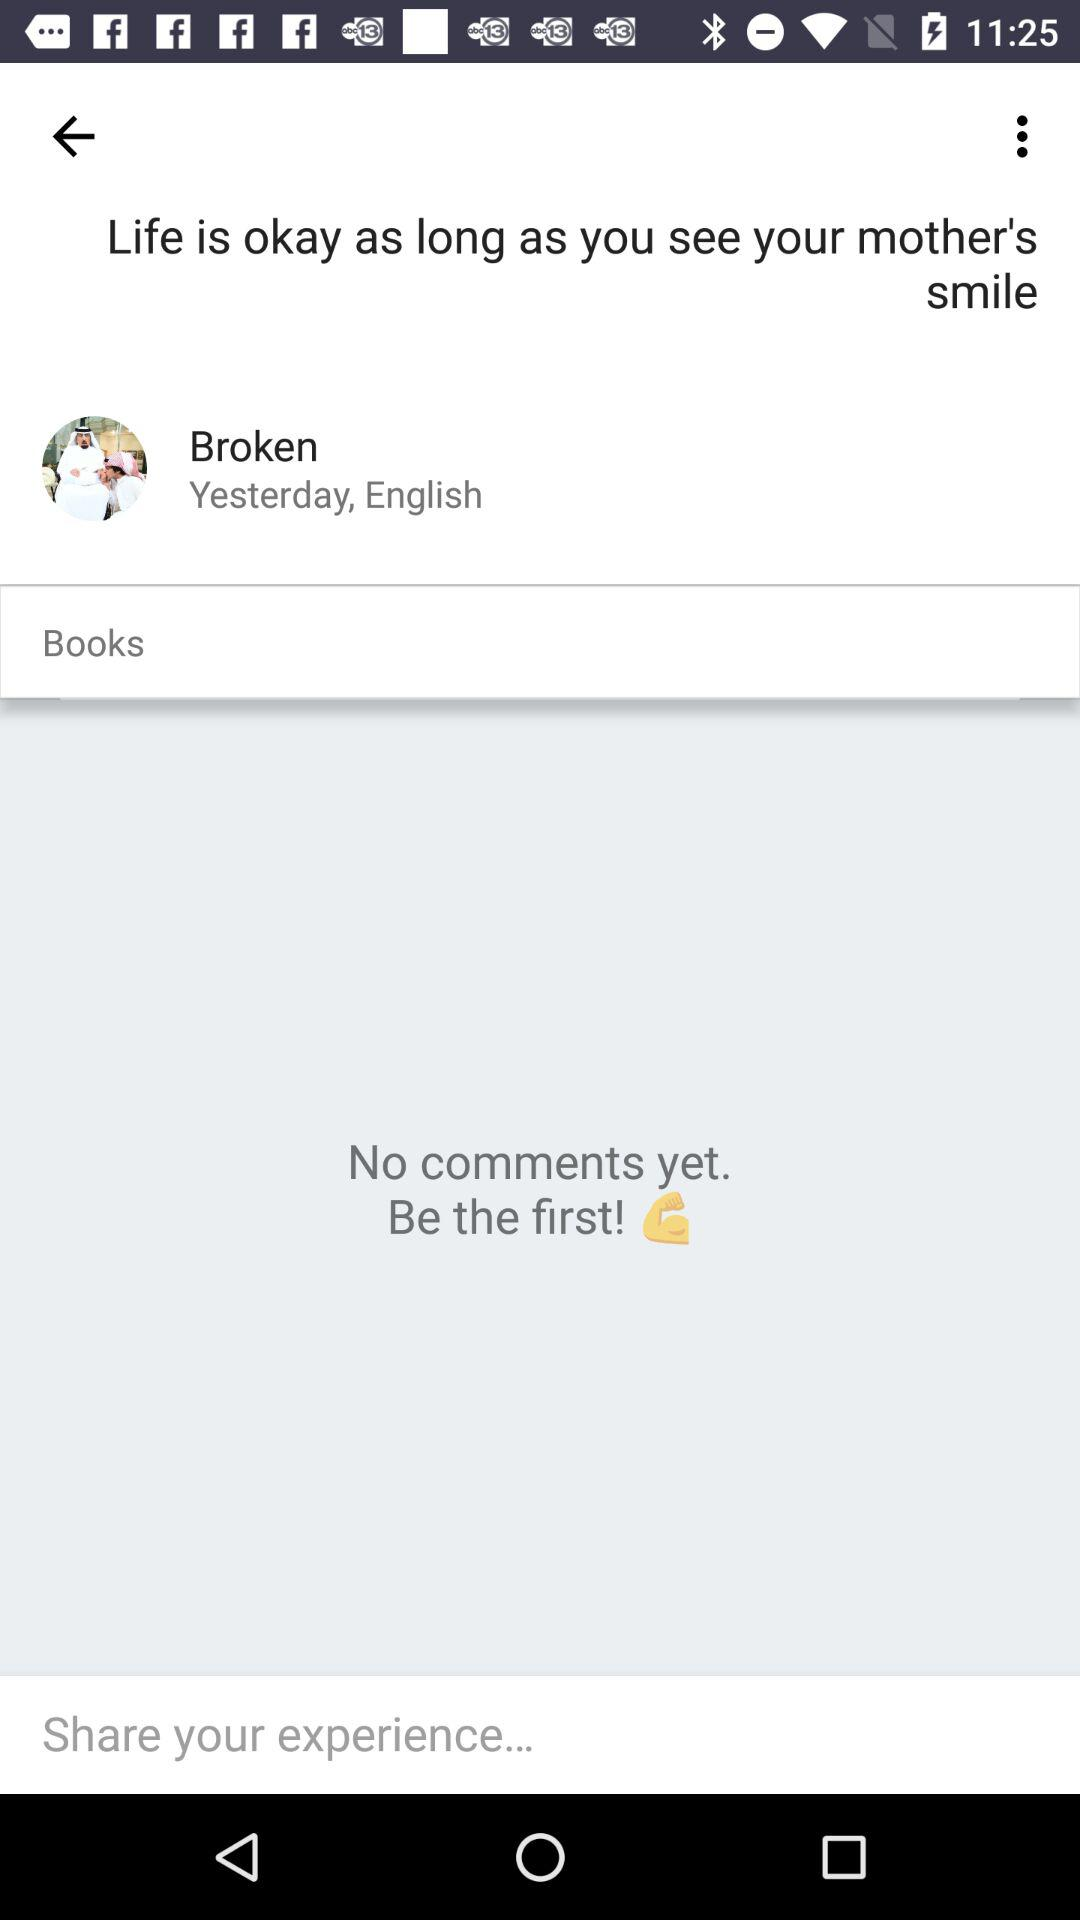Is there any comment? There are no comments. 